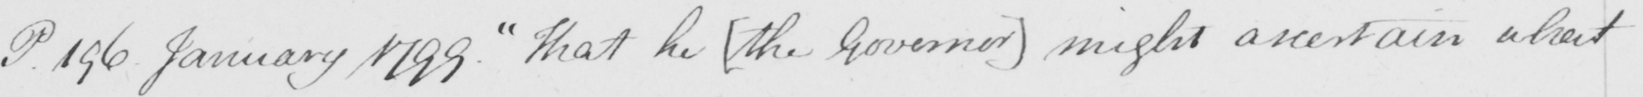What does this handwritten line say? P. 196 January 1799. "That he [the Governor] might ascertain what 